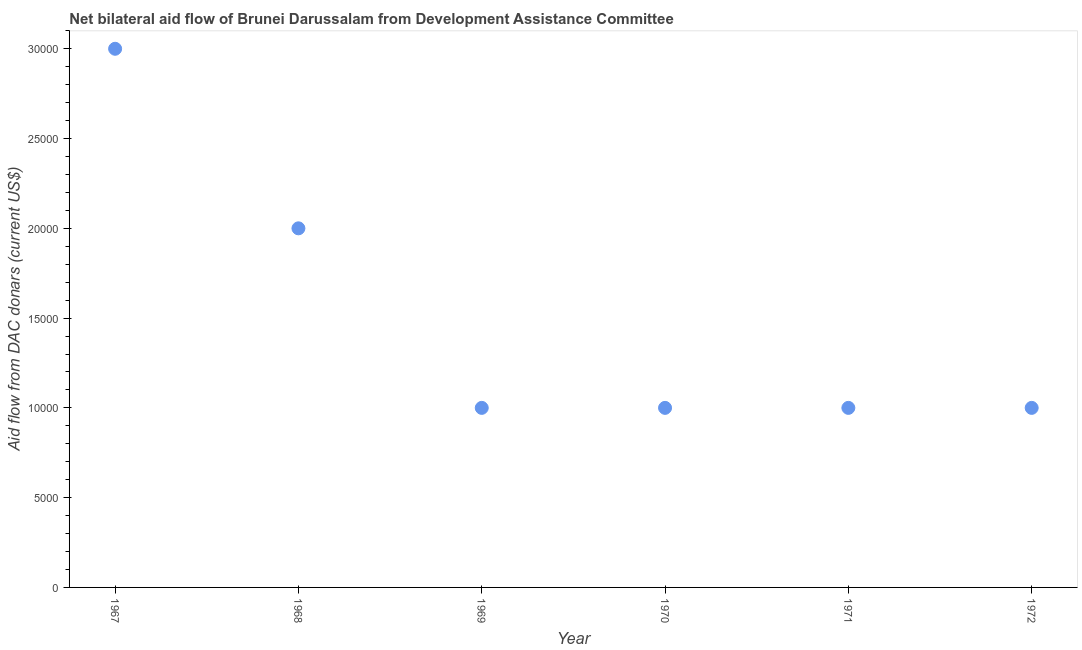What is the net bilateral aid flows from dac donors in 1968?
Offer a terse response. 2.00e+04. Across all years, what is the maximum net bilateral aid flows from dac donors?
Your answer should be very brief. 3.00e+04. Across all years, what is the minimum net bilateral aid flows from dac donors?
Make the answer very short. 10000. In which year was the net bilateral aid flows from dac donors maximum?
Your answer should be very brief. 1967. In which year was the net bilateral aid flows from dac donors minimum?
Provide a short and direct response. 1969. What is the sum of the net bilateral aid flows from dac donors?
Offer a very short reply. 9.00e+04. What is the average net bilateral aid flows from dac donors per year?
Offer a very short reply. 1.50e+04. Do a majority of the years between 1967 and 1969 (inclusive) have net bilateral aid flows from dac donors greater than 2000 US$?
Offer a terse response. Yes. What is the ratio of the net bilateral aid flows from dac donors in 1968 to that in 1972?
Keep it short and to the point. 2. Is the difference between the net bilateral aid flows from dac donors in 1967 and 1972 greater than the difference between any two years?
Offer a terse response. Yes. What is the difference between the highest and the second highest net bilateral aid flows from dac donors?
Provide a short and direct response. 10000. Is the sum of the net bilateral aid flows from dac donors in 1967 and 1969 greater than the maximum net bilateral aid flows from dac donors across all years?
Your response must be concise. Yes. What is the difference between the highest and the lowest net bilateral aid flows from dac donors?
Ensure brevity in your answer.  2.00e+04. Does the net bilateral aid flows from dac donors monotonically increase over the years?
Provide a succinct answer. No. How many dotlines are there?
Make the answer very short. 1. How many years are there in the graph?
Offer a very short reply. 6. What is the difference between two consecutive major ticks on the Y-axis?
Your answer should be very brief. 5000. Are the values on the major ticks of Y-axis written in scientific E-notation?
Make the answer very short. No. What is the title of the graph?
Ensure brevity in your answer.  Net bilateral aid flow of Brunei Darussalam from Development Assistance Committee. What is the label or title of the X-axis?
Provide a succinct answer. Year. What is the label or title of the Y-axis?
Provide a short and direct response. Aid flow from DAC donars (current US$). What is the Aid flow from DAC donars (current US$) in 1967?
Give a very brief answer. 3.00e+04. What is the Aid flow from DAC donars (current US$) in 1969?
Your response must be concise. 10000. What is the Aid flow from DAC donars (current US$) in 1970?
Offer a very short reply. 10000. What is the Aid flow from DAC donars (current US$) in 1971?
Ensure brevity in your answer.  10000. What is the difference between the Aid flow from DAC donars (current US$) in 1967 and 1968?
Your answer should be very brief. 10000. What is the difference between the Aid flow from DAC donars (current US$) in 1967 and 1970?
Your response must be concise. 2.00e+04. What is the difference between the Aid flow from DAC donars (current US$) in 1967 and 1971?
Offer a very short reply. 2.00e+04. What is the difference between the Aid flow from DAC donars (current US$) in 1967 and 1972?
Provide a short and direct response. 2.00e+04. What is the difference between the Aid flow from DAC donars (current US$) in 1968 and 1969?
Ensure brevity in your answer.  10000. What is the difference between the Aid flow from DAC donars (current US$) in 1968 and 1970?
Provide a succinct answer. 10000. What is the difference between the Aid flow from DAC donars (current US$) in 1968 and 1971?
Provide a short and direct response. 10000. What is the difference between the Aid flow from DAC donars (current US$) in 1968 and 1972?
Your answer should be compact. 10000. What is the difference between the Aid flow from DAC donars (current US$) in 1969 and 1971?
Your answer should be compact. 0. What is the difference between the Aid flow from DAC donars (current US$) in 1969 and 1972?
Your answer should be very brief. 0. What is the difference between the Aid flow from DAC donars (current US$) in 1970 and 1972?
Give a very brief answer. 0. What is the difference between the Aid flow from DAC donars (current US$) in 1971 and 1972?
Your answer should be compact. 0. What is the ratio of the Aid flow from DAC donars (current US$) in 1967 to that in 1969?
Offer a very short reply. 3. What is the ratio of the Aid flow from DAC donars (current US$) in 1967 to that in 1971?
Your response must be concise. 3. What is the ratio of the Aid flow from DAC donars (current US$) in 1968 to that in 1970?
Make the answer very short. 2. What is the ratio of the Aid flow from DAC donars (current US$) in 1968 to that in 1972?
Your answer should be compact. 2. What is the ratio of the Aid flow from DAC donars (current US$) in 1969 to that in 1971?
Your answer should be compact. 1. What is the ratio of the Aid flow from DAC donars (current US$) in 1970 to that in 1972?
Your answer should be compact. 1. What is the ratio of the Aid flow from DAC donars (current US$) in 1971 to that in 1972?
Provide a succinct answer. 1. 